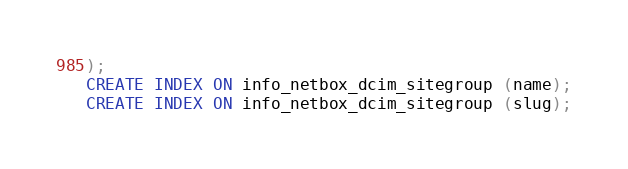<code> <loc_0><loc_0><loc_500><loc_500><_SQL_>);
CREATE INDEX ON info_netbox_dcim_sitegroup (name);
CREATE INDEX ON info_netbox_dcim_sitegroup (slug);</code> 